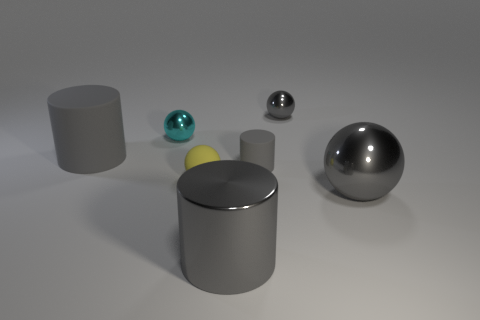There is a rubber thing that is the same shape as the cyan shiny object; what is its color?
Make the answer very short. Yellow. What is the size of the cyan ball?
Provide a short and direct response. Small. How many spheres are tiny yellow objects or big matte things?
Provide a succinct answer. 1. What size is the other gray object that is the same shape as the small gray metallic thing?
Your answer should be very brief. Large. How many gray rubber things are there?
Your answer should be very brief. 2. Does the tiny gray rubber object have the same shape as the gray matte object that is on the left side of the tiny yellow rubber sphere?
Give a very brief answer. Yes. There is a metal thing that is to the left of the yellow matte sphere; how big is it?
Your answer should be very brief. Small. What material is the yellow object?
Your answer should be compact. Rubber. Is the shape of the gray object that is behind the tiny cyan metal ball the same as  the small gray rubber thing?
Ensure brevity in your answer.  No. The other sphere that is the same color as the big metallic ball is what size?
Keep it short and to the point. Small. 